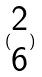Convert formula to latex. <formula><loc_0><loc_0><loc_500><loc_500>( \begin{matrix} 2 \\ 6 \end{matrix} )</formula> 